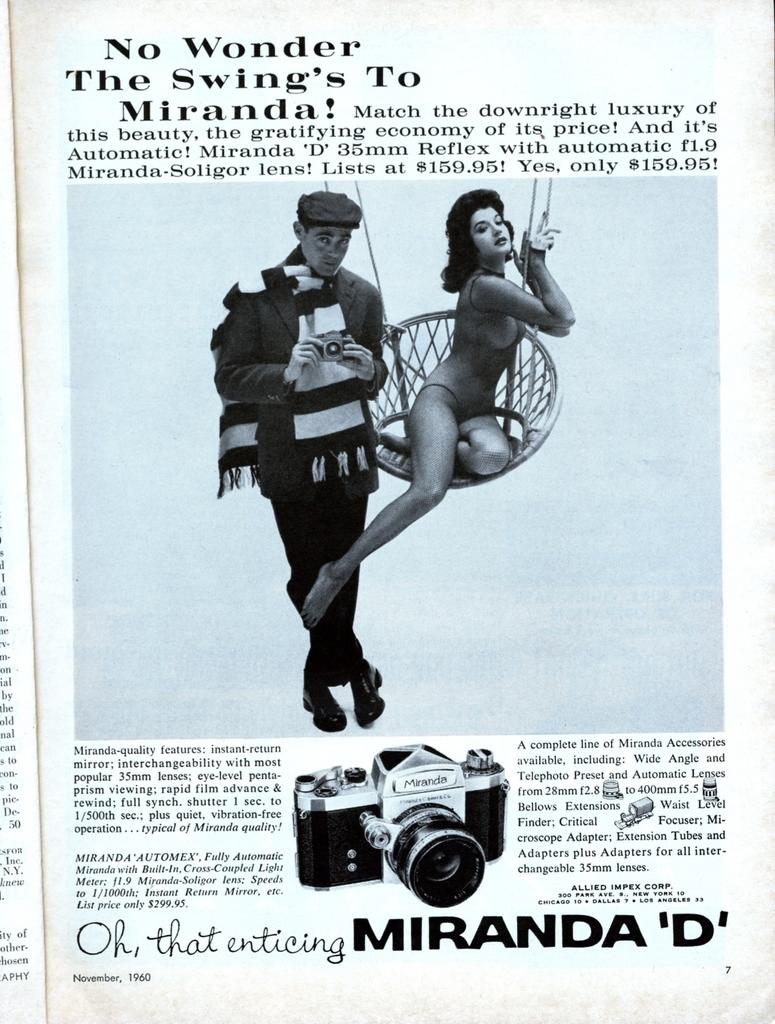What is present in the image that features a visual representation? There is a poster in the image. What can be seen in the picture on the poster? The poster contains a picture of two people. What else is included on the poster besides the image? There is text written on the poster. Can you describe the store that is visible in the image? There is no store present in the image; it features a poster with a picture of two people and text. What type of ocean can be seen in the image? There is no ocean present in the image; it features a poster with a picture of two people and text. 